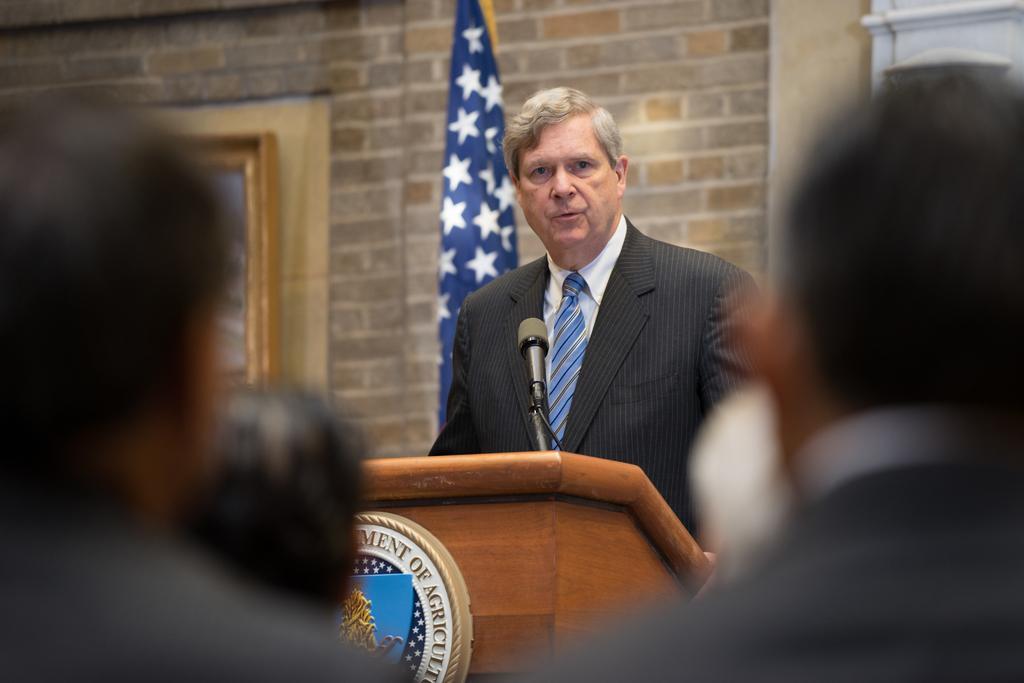Can you describe this image briefly? In this image, I can see the man standing. This looks like a name board, which is attached to a podium. Here is the mike. This looks like a flag hanging. I can see the heads of few people. In the background, I think this is a frame, which is attached to a wall. 